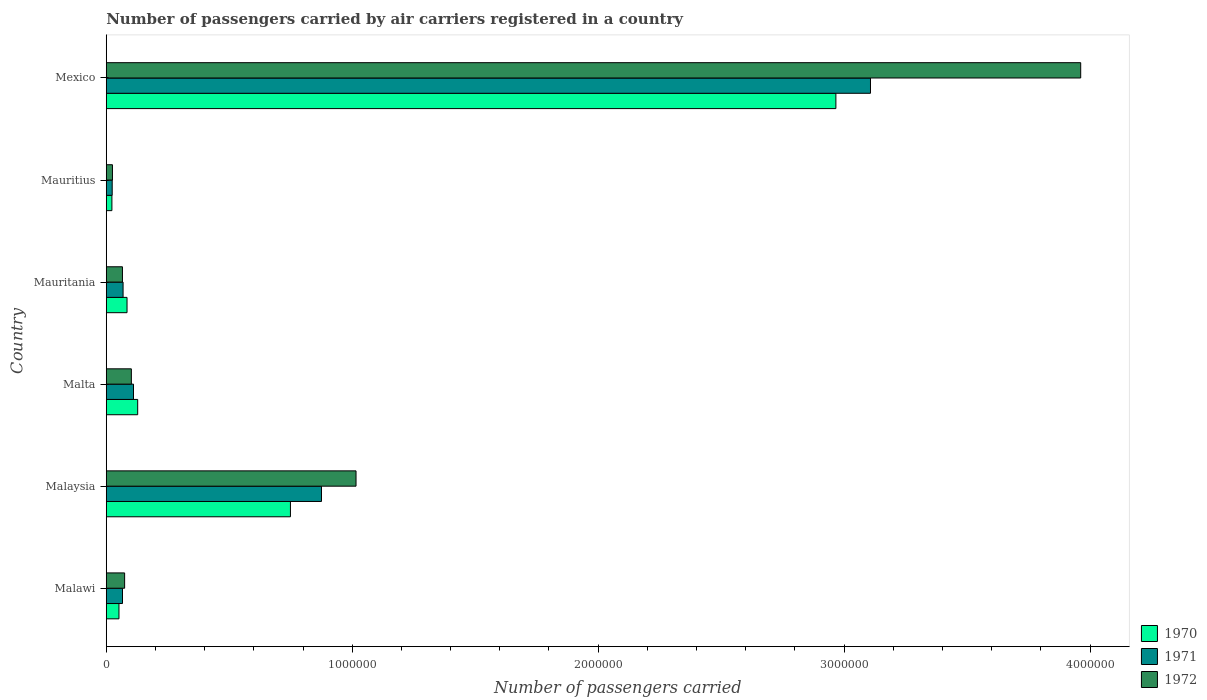How many different coloured bars are there?
Your response must be concise. 3. Are the number of bars on each tick of the Y-axis equal?
Provide a succinct answer. Yes. How many bars are there on the 1st tick from the top?
Offer a very short reply. 3. What is the label of the 6th group of bars from the top?
Provide a succinct answer. Malawi. What is the number of passengers carried by air carriers in 1971 in Malawi?
Make the answer very short. 6.61e+04. Across all countries, what is the maximum number of passengers carried by air carriers in 1971?
Ensure brevity in your answer.  3.11e+06. Across all countries, what is the minimum number of passengers carried by air carriers in 1971?
Keep it short and to the point. 2.42e+04. In which country was the number of passengers carried by air carriers in 1972 maximum?
Make the answer very short. Mexico. In which country was the number of passengers carried by air carriers in 1972 minimum?
Your response must be concise. Mauritius. What is the total number of passengers carried by air carriers in 1971 in the graph?
Your answer should be compact. 4.25e+06. What is the difference between the number of passengers carried by air carriers in 1970 in Malawi and that in Malta?
Offer a terse response. -7.61e+04. What is the difference between the number of passengers carried by air carriers in 1971 in Malta and the number of passengers carried by air carriers in 1972 in Mexico?
Your answer should be very brief. -3.85e+06. What is the average number of passengers carried by air carriers in 1972 per country?
Offer a terse response. 8.74e+05. What is the difference between the number of passengers carried by air carriers in 1972 and number of passengers carried by air carriers in 1970 in Malaysia?
Offer a very short reply. 2.67e+05. What is the ratio of the number of passengers carried by air carriers in 1972 in Malawi to that in Mauritius?
Your answer should be compact. 2.96. Is the number of passengers carried by air carriers in 1972 in Malaysia less than that in Mexico?
Offer a terse response. Yes. Is the difference between the number of passengers carried by air carriers in 1972 in Malaysia and Mauritius greater than the difference between the number of passengers carried by air carriers in 1970 in Malaysia and Mauritius?
Provide a short and direct response. Yes. What is the difference between the highest and the second highest number of passengers carried by air carriers in 1971?
Provide a succinct answer. 2.23e+06. What is the difference between the highest and the lowest number of passengers carried by air carriers in 1970?
Offer a very short reply. 2.94e+06. In how many countries, is the number of passengers carried by air carriers in 1970 greater than the average number of passengers carried by air carriers in 1970 taken over all countries?
Offer a terse response. 2. What does the 2nd bar from the top in Malaysia represents?
Provide a succinct answer. 1971. Are all the bars in the graph horizontal?
Your answer should be very brief. Yes. What is the difference between two consecutive major ticks on the X-axis?
Your answer should be compact. 1.00e+06. Are the values on the major ticks of X-axis written in scientific E-notation?
Provide a short and direct response. No. Does the graph contain any zero values?
Provide a succinct answer. No. How are the legend labels stacked?
Your answer should be compact. Vertical. What is the title of the graph?
Ensure brevity in your answer.  Number of passengers carried by air carriers registered in a country. What is the label or title of the X-axis?
Offer a terse response. Number of passengers carried. What is the label or title of the Y-axis?
Give a very brief answer. Country. What is the Number of passengers carried of 1970 in Malawi?
Keep it short and to the point. 5.17e+04. What is the Number of passengers carried in 1971 in Malawi?
Give a very brief answer. 6.61e+04. What is the Number of passengers carried of 1972 in Malawi?
Your response must be concise. 7.47e+04. What is the Number of passengers carried in 1970 in Malaysia?
Offer a terse response. 7.49e+05. What is the Number of passengers carried of 1971 in Malaysia?
Your answer should be very brief. 8.75e+05. What is the Number of passengers carried of 1972 in Malaysia?
Offer a very short reply. 1.02e+06. What is the Number of passengers carried in 1970 in Malta?
Keep it short and to the point. 1.28e+05. What is the Number of passengers carried in 1971 in Malta?
Offer a very short reply. 1.11e+05. What is the Number of passengers carried in 1972 in Malta?
Your answer should be compact. 1.02e+05. What is the Number of passengers carried of 1970 in Mauritania?
Keep it short and to the point. 8.45e+04. What is the Number of passengers carried in 1971 in Mauritania?
Provide a short and direct response. 6.84e+04. What is the Number of passengers carried in 1972 in Mauritania?
Your response must be concise. 6.59e+04. What is the Number of passengers carried in 1970 in Mauritius?
Keep it short and to the point. 2.30e+04. What is the Number of passengers carried in 1971 in Mauritius?
Ensure brevity in your answer.  2.42e+04. What is the Number of passengers carried of 1972 in Mauritius?
Your answer should be very brief. 2.52e+04. What is the Number of passengers carried in 1970 in Mexico?
Your response must be concise. 2.97e+06. What is the Number of passengers carried in 1971 in Mexico?
Provide a short and direct response. 3.11e+06. What is the Number of passengers carried in 1972 in Mexico?
Offer a terse response. 3.96e+06. Across all countries, what is the maximum Number of passengers carried of 1970?
Give a very brief answer. 2.97e+06. Across all countries, what is the maximum Number of passengers carried in 1971?
Keep it short and to the point. 3.11e+06. Across all countries, what is the maximum Number of passengers carried of 1972?
Provide a succinct answer. 3.96e+06. Across all countries, what is the minimum Number of passengers carried in 1970?
Provide a short and direct response. 2.30e+04. Across all countries, what is the minimum Number of passengers carried in 1971?
Keep it short and to the point. 2.42e+04. Across all countries, what is the minimum Number of passengers carried of 1972?
Offer a terse response. 2.52e+04. What is the total Number of passengers carried in 1970 in the graph?
Give a very brief answer. 4.00e+06. What is the total Number of passengers carried in 1971 in the graph?
Offer a terse response. 4.25e+06. What is the total Number of passengers carried of 1972 in the graph?
Ensure brevity in your answer.  5.25e+06. What is the difference between the Number of passengers carried in 1970 in Malawi and that in Malaysia?
Your answer should be very brief. -6.97e+05. What is the difference between the Number of passengers carried of 1971 in Malawi and that in Malaysia?
Provide a short and direct response. -8.09e+05. What is the difference between the Number of passengers carried in 1972 in Malawi and that in Malaysia?
Give a very brief answer. -9.41e+05. What is the difference between the Number of passengers carried in 1970 in Malawi and that in Malta?
Your answer should be compact. -7.61e+04. What is the difference between the Number of passengers carried in 1971 in Malawi and that in Malta?
Give a very brief answer. -4.47e+04. What is the difference between the Number of passengers carried in 1972 in Malawi and that in Malta?
Provide a short and direct response. -2.74e+04. What is the difference between the Number of passengers carried of 1970 in Malawi and that in Mauritania?
Ensure brevity in your answer.  -3.28e+04. What is the difference between the Number of passengers carried in 1971 in Malawi and that in Mauritania?
Your answer should be very brief. -2300. What is the difference between the Number of passengers carried in 1972 in Malawi and that in Mauritania?
Provide a succinct answer. 8800. What is the difference between the Number of passengers carried in 1970 in Malawi and that in Mauritius?
Your answer should be compact. 2.87e+04. What is the difference between the Number of passengers carried of 1971 in Malawi and that in Mauritius?
Your answer should be very brief. 4.19e+04. What is the difference between the Number of passengers carried in 1972 in Malawi and that in Mauritius?
Provide a short and direct response. 4.95e+04. What is the difference between the Number of passengers carried of 1970 in Malawi and that in Mexico?
Offer a terse response. -2.91e+06. What is the difference between the Number of passengers carried in 1971 in Malawi and that in Mexico?
Make the answer very short. -3.04e+06. What is the difference between the Number of passengers carried in 1972 in Malawi and that in Mexico?
Your answer should be compact. -3.89e+06. What is the difference between the Number of passengers carried in 1970 in Malaysia and that in Malta?
Make the answer very short. 6.21e+05. What is the difference between the Number of passengers carried in 1971 in Malaysia and that in Malta?
Keep it short and to the point. 7.64e+05. What is the difference between the Number of passengers carried in 1972 in Malaysia and that in Malta?
Make the answer very short. 9.14e+05. What is the difference between the Number of passengers carried of 1970 in Malaysia and that in Mauritania?
Provide a succinct answer. 6.64e+05. What is the difference between the Number of passengers carried of 1971 in Malaysia and that in Mauritania?
Offer a terse response. 8.07e+05. What is the difference between the Number of passengers carried of 1972 in Malaysia and that in Mauritania?
Offer a very short reply. 9.50e+05. What is the difference between the Number of passengers carried of 1970 in Malaysia and that in Mauritius?
Keep it short and to the point. 7.26e+05. What is the difference between the Number of passengers carried in 1971 in Malaysia and that in Mauritius?
Offer a terse response. 8.51e+05. What is the difference between the Number of passengers carried of 1972 in Malaysia and that in Mauritius?
Keep it short and to the point. 9.90e+05. What is the difference between the Number of passengers carried of 1970 in Malaysia and that in Mexico?
Ensure brevity in your answer.  -2.22e+06. What is the difference between the Number of passengers carried in 1971 in Malaysia and that in Mexico?
Make the answer very short. -2.23e+06. What is the difference between the Number of passengers carried in 1972 in Malaysia and that in Mexico?
Make the answer very short. -2.95e+06. What is the difference between the Number of passengers carried in 1970 in Malta and that in Mauritania?
Make the answer very short. 4.33e+04. What is the difference between the Number of passengers carried in 1971 in Malta and that in Mauritania?
Offer a very short reply. 4.24e+04. What is the difference between the Number of passengers carried of 1972 in Malta and that in Mauritania?
Your answer should be very brief. 3.62e+04. What is the difference between the Number of passengers carried in 1970 in Malta and that in Mauritius?
Ensure brevity in your answer.  1.05e+05. What is the difference between the Number of passengers carried in 1971 in Malta and that in Mauritius?
Your response must be concise. 8.66e+04. What is the difference between the Number of passengers carried of 1972 in Malta and that in Mauritius?
Offer a very short reply. 7.69e+04. What is the difference between the Number of passengers carried of 1970 in Malta and that in Mexico?
Ensure brevity in your answer.  -2.84e+06. What is the difference between the Number of passengers carried in 1971 in Malta and that in Mexico?
Make the answer very short. -3.00e+06. What is the difference between the Number of passengers carried in 1972 in Malta and that in Mexico?
Give a very brief answer. -3.86e+06. What is the difference between the Number of passengers carried in 1970 in Mauritania and that in Mauritius?
Offer a terse response. 6.15e+04. What is the difference between the Number of passengers carried in 1971 in Mauritania and that in Mauritius?
Provide a succinct answer. 4.42e+04. What is the difference between the Number of passengers carried of 1972 in Mauritania and that in Mauritius?
Keep it short and to the point. 4.07e+04. What is the difference between the Number of passengers carried of 1970 in Mauritania and that in Mexico?
Offer a very short reply. -2.88e+06. What is the difference between the Number of passengers carried in 1971 in Mauritania and that in Mexico?
Provide a succinct answer. -3.04e+06. What is the difference between the Number of passengers carried of 1972 in Mauritania and that in Mexico?
Keep it short and to the point. -3.90e+06. What is the difference between the Number of passengers carried in 1970 in Mauritius and that in Mexico?
Make the answer very short. -2.94e+06. What is the difference between the Number of passengers carried in 1971 in Mauritius and that in Mexico?
Ensure brevity in your answer.  -3.08e+06. What is the difference between the Number of passengers carried of 1972 in Mauritius and that in Mexico?
Offer a terse response. -3.94e+06. What is the difference between the Number of passengers carried of 1970 in Malawi and the Number of passengers carried of 1971 in Malaysia?
Keep it short and to the point. -8.23e+05. What is the difference between the Number of passengers carried in 1970 in Malawi and the Number of passengers carried in 1972 in Malaysia?
Keep it short and to the point. -9.64e+05. What is the difference between the Number of passengers carried in 1971 in Malawi and the Number of passengers carried in 1972 in Malaysia?
Give a very brief answer. -9.50e+05. What is the difference between the Number of passengers carried in 1970 in Malawi and the Number of passengers carried in 1971 in Malta?
Your answer should be compact. -5.91e+04. What is the difference between the Number of passengers carried in 1970 in Malawi and the Number of passengers carried in 1972 in Malta?
Your answer should be very brief. -5.04e+04. What is the difference between the Number of passengers carried of 1971 in Malawi and the Number of passengers carried of 1972 in Malta?
Offer a terse response. -3.60e+04. What is the difference between the Number of passengers carried of 1970 in Malawi and the Number of passengers carried of 1971 in Mauritania?
Give a very brief answer. -1.67e+04. What is the difference between the Number of passengers carried of 1970 in Malawi and the Number of passengers carried of 1972 in Mauritania?
Provide a short and direct response. -1.42e+04. What is the difference between the Number of passengers carried of 1970 in Malawi and the Number of passengers carried of 1971 in Mauritius?
Ensure brevity in your answer.  2.75e+04. What is the difference between the Number of passengers carried of 1970 in Malawi and the Number of passengers carried of 1972 in Mauritius?
Make the answer very short. 2.65e+04. What is the difference between the Number of passengers carried of 1971 in Malawi and the Number of passengers carried of 1972 in Mauritius?
Your answer should be compact. 4.09e+04. What is the difference between the Number of passengers carried of 1970 in Malawi and the Number of passengers carried of 1971 in Mexico?
Keep it short and to the point. -3.06e+06. What is the difference between the Number of passengers carried in 1970 in Malawi and the Number of passengers carried in 1972 in Mexico?
Make the answer very short. -3.91e+06. What is the difference between the Number of passengers carried of 1971 in Malawi and the Number of passengers carried of 1972 in Mexico?
Give a very brief answer. -3.90e+06. What is the difference between the Number of passengers carried in 1970 in Malaysia and the Number of passengers carried in 1971 in Malta?
Your answer should be very brief. 6.38e+05. What is the difference between the Number of passengers carried in 1970 in Malaysia and the Number of passengers carried in 1972 in Malta?
Provide a succinct answer. 6.47e+05. What is the difference between the Number of passengers carried in 1971 in Malaysia and the Number of passengers carried in 1972 in Malta?
Provide a short and direct response. 7.73e+05. What is the difference between the Number of passengers carried of 1970 in Malaysia and the Number of passengers carried of 1971 in Mauritania?
Offer a very short reply. 6.80e+05. What is the difference between the Number of passengers carried in 1970 in Malaysia and the Number of passengers carried in 1972 in Mauritania?
Offer a very short reply. 6.83e+05. What is the difference between the Number of passengers carried of 1971 in Malaysia and the Number of passengers carried of 1972 in Mauritania?
Offer a terse response. 8.09e+05. What is the difference between the Number of passengers carried of 1970 in Malaysia and the Number of passengers carried of 1971 in Mauritius?
Ensure brevity in your answer.  7.25e+05. What is the difference between the Number of passengers carried of 1970 in Malaysia and the Number of passengers carried of 1972 in Mauritius?
Provide a short and direct response. 7.24e+05. What is the difference between the Number of passengers carried of 1971 in Malaysia and the Number of passengers carried of 1972 in Mauritius?
Your answer should be compact. 8.50e+05. What is the difference between the Number of passengers carried in 1970 in Malaysia and the Number of passengers carried in 1971 in Mexico?
Keep it short and to the point. -2.36e+06. What is the difference between the Number of passengers carried in 1970 in Malaysia and the Number of passengers carried in 1972 in Mexico?
Provide a succinct answer. -3.21e+06. What is the difference between the Number of passengers carried of 1971 in Malaysia and the Number of passengers carried of 1972 in Mexico?
Your answer should be very brief. -3.09e+06. What is the difference between the Number of passengers carried in 1970 in Malta and the Number of passengers carried in 1971 in Mauritania?
Your response must be concise. 5.94e+04. What is the difference between the Number of passengers carried of 1970 in Malta and the Number of passengers carried of 1972 in Mauritania?
Your response must be concise. 6.19e+04. What is the difference between the Number of passengers carried of 1971 in Malta and the Number of passengers carried of 1972 in Mauritania?
Keep it short and to the point. 4.49e+04. What is the difference between the Number of passengers carried of 1970 in Malta and the Number of passengers carried of 1971 in Mauritius?
Give a very brief answer. 1.04e+05. What is the difference between the Number of passengers carried of 1970 in Malta and the Number of passengers carried of 1972 in Mauritius?
Your answer should be very brief. 1.03e+05. What is the difference between the Number of passengers carried of 1971 in Malta and the Number of passengers carried of 1972 in Mauritius?
Your response must be concise. 8.56e+04. What is the difference between the Number of passengers carried of 1970 in Malta and the Number of passengers carried of 1971 in Mexico?
Give a very brief answer. -2.98e+06. What is the difference between the Number of passengers carried in 1970 in Malta and the Number of passengers carried in 1972 in Mexico?
Keep it short and to the point. -3.83e+06. What is the difference between the Number of passengers carried in 1971 in Malta and the Number of passengers carried in 1972 in Mexico?
Make the answer very short. -3.85e+06. What is the difference between the Number of passengers carried of 1970 in Mauritania and the Number of passengers carried of 1971 in Mauritius?
Provide a short and direct response. 6.03e+04. What is the difference between the Number of passengers carried of 1970 in Mauritania and the Number of passengers carried of 1972 in Mauritius?
Make the answer very short. 5.93e+04. What is the difference between the Number of passengers carried of 1971 in Mauritania and the Number of passengers carried of 1972 in Mauritius?
Provide a short and direct response. 4.32e+04. What is the difference between the Number of passengers carried in 1970 in Mauritania and the Number of passengers carried in 1971 in Mexico?
Offer a terse response. -3.02e+06. What is the difference between the Number of passengers carried of 1970 in Mauritania and the Number of passengers carried of 1972 in Mexico?
Provide a short and direct response. -3.88e+06. What is the difference between the Number of passengers carried in 1971 in Mauritania and the Number of passengers carried in 1972 in Mexico?
Your response must be concise. -3.89e+06. What is the difference between the Number of passengers carried in 1970 in Mauritius and the Number of passengers carried in 1971 in Mexico?
Keep it short and to the point. -3.08e+06. What is the difference between the Number of passengers carried in 1970 in Mauritius and the Number of passengers carried in 1972 in Mexico?
Provide a short and direct response. -3.94e+06. What is the difference between the Number of passengers carried of 1971 in Mauritius and the Number of passengers carried of 1972 in Mexico?
Provide a short and direct response. -3.94e+06. What is the average Number of passengers carried in 1970 per country?
Your answer should be compact. 6.67e+05. What is the average Number of passengers carried of 1971 per country?
Your answer should be very brief. 7.09e+05. What is the average Number of passengers carried in 1972 per country?
Your answer should be very brief. 8.74e+05. What is the difference between the Number of passengers carried of 1970 and Number of passengers carried of 1971 in Malawi?
Make the answer very short. -1.44e+04. What is the difference between the Number of passengers carried of 1970 and Number of passengers carried of 1972 in Malawi?
Provide a succinct answer. -2.30e+04. What is the difference between the Number of passengers carried of 1971 and Number of passengers carried of 1972 in Malawi?
Offer a very short reply. -8600. What is the difference between the Number of passengers carried of 1970 and Number of passengers carried of 1971 in Malaysia?
Keep it short and to the point. -1.26e+05. What is the difference between the Number of passengers carried of 1970 and Number of passengers carried of 1972 in Malaysia?
Provide a short and direct response. -2.67e+05. What is the difference between the Number of passengers carried of 1971 and Number of passengers carried of 1972 in Malaysia?
Your answer should be very brief. -1.40e+05. What is the difference between the Number of passengers carried in 1970 and Number of passengers carried in 1971 in Malta?
Your answer should be very brief. 1.70e+04. What is the difference between the Number of passengers carried in 1970 and Number of passengers carried in 1972 in Malta?
Your response must be concise. 2.57e+04. What is the difference between the Number of passengers carried of 1971 and Number of passengers carried of 1972 in Malta?
Give a very brief answer. 8700. What is the difference between the Number of passengers carried in 1970 and Number of passengers carried in 1971 in Mauritania?
Provide a succinct answer. 1.61e+04. What is the difference between the Number of passengers carried of 1970 and Number of passengers carried of 1972 in Mauritania?
Offer a very short reply. 1.86e+04. What is the difference between the Number of passengers carried of 1971 and Number of passengers carried of 1972 in Mauritania?
Your answer should be compact. 2500. What is the difference between the Number of passengers carried of 1970 and Number of passengers carried of 1971 in Mauritius?
Your answer should be very brief. -1200. What is the difference between the Number of passengers carried of 1970 and Number of passengers carried of 1972 in Mauritius?
Provide a succinct answer. -2200. What is the difference between the Number of passengers carried in 1971 and Number of passengers carried in 1972 in Mauritius?
Give a very brief answer. -1000. What is the difference between the Number of passengers carried of 1970 and Number of passengers carried of 1971 in Mexico?
Provide a short and direct response. -1.41e+05. What is the difference between the Number of passengers carried of 1970 and Number of passengers carried of 1972 in Mexico?
Offer a very short reply. -9.95e+05. What is the difference between the Number of passengers carried of 1971 and Number of passengers carried of 1972 in Mexico?
Give a very brief answer. -8.55e+05. What is the ratio of the Number of passengers carried in 1970 in Malawi to that in Malaysia?
Your response must be concise. 0.07. What is the ratio of the Number of passengers carried in 1971 in Malawi to that in Malaysia?
Offer a terse response. 0.08. What is the ratio of the Number of passengers carried in 1972 in Malawi to that in Malaysia?
Your response must be concise. 0.07. What is the ratio of the Number of passengers carried of 1970 in Malawi to that in Malta?
Offer a terse response. 0.4. What is the ratio of the Number of passengers carried in 1971 in Malawi to that in Malta?
Provide a succinct answer. 0.6. What is the ratio of the Number of passengers carried in 1972 in Malawi to that in Malta?
Ensure brevity in your answer.  0.73. What is the ratio of the Number of passengers carried in 1970 in Malawi to that in Mauritania?
Offer a very short reply. 0.61. What is the ratio of the Number of passengers carried in 1971 in Malawi to that in Mauritania?
Make the answer very short. 0.97. What is the ratio of the Number of passengers carried of 1972 in Malawi to that in Mauritania?
Provide a succinct answer. 1.13. What is the ratio of the Number of passengers carried of 1970 in Malawi to that in Mauritius?
Provide a short and direct response. 2.25. What is the ratio of the Number of passengers carried in 1971 in Malawi to that in Mauritius?
Your answer should be compact. 2.73. What is the ratio of the Number of passengers carried of 1972 in Malawi to that in Mauritius?
Your answer should be compact. 2.96. What is the ratio of the Number of passengers carried of 1970 in Malawi to that in Mexico?
Your response must be concise. 0.02. What is the ratio of the Number of passengers carried in 1971 in Malawi to that in Mexico?
Keep it short and to the point. 0.02. What is the ratio of the Number of passengers carried in 1972 in Malawi to that in Mexico?
Your response must be concise. 0.02. What is the ratio of the Number of passengers carried in 1970 in Malaysia to that in Malta?
Make the answer very short. 5.86. What is the ratio of the Number of passengers carried of 1971 in Malaysia to that in Malta?
Your answer should be compact. 7.9. What is the ratio of the Number of passengers carried of 1972 in Malaysia to that in Malta?
Your answer should be compact. 9.95. What is the ratio of the Number of passengers carried of 1970 in Malaysia to that in Mauritania?
Make the answer very short. 8.86. What is the ratio of the Number of passengers carried of 1971 in Malaysia to that in Mauritania?
Your response must be concise. 12.79. What is the ratio of the Number of passengers carried of 1972 in Malaysia to that in Mauritania?
Make the answer very short. 15.41. What is the ratio of the Number of passengers carried in 1970 in Malaysia to that in Mauritius?
Offer a very short reply. 32.56. What is the ratio of the Number of passengers carried in 1971 in Malaysia to that in Mauritius?
Provide a short and direct response. 36.16. What is the ratio of the Number of passengers carried in 1972 in Malaysia to that in Mauritius?
Provide a succinct answer. 40.3. What is the ratio of the Number of passengers carried of 1970 in Malaysia to that in Mexico?
Your answer should be compact. 0.25. What is the ratio of the Number of passengers carried of 1971 in Malaysia to that in Mexico?
Ensure brevity in your answer.  0.28. What is the ratio of the Number of passengers carried in 1972 in Malaysia to that in Mexico?
Your answer should be very brief. 0.26. What is the ratio of the Number of passengers carried in 1970 in Malta to that in Mauritania?
Your answer should be compact. 1.51. What is the ratio of the Number of passengers carried in 1971 in Malta to that in Mauritania?
Give a very brief answer. 1.62. What is the ratio of the Number of passengers carried in 1972 in Malta to that in Mauritania?
Your answer should be very brief. 1.55. What is the ratio of the Number of passengers carried in 1970 in Malta to that in Mauritius?
Provide a short and direct response. 5.56. What is the ratio of the Number of passengers carried in 1971 in Malta to that in Mauritius?
Provide a short and direct response. 4.58. What is the ratio of the Number of passengers carried of 1972 in Malta to that in Mauritius?
Offer a terse response. 4.05. What is the ratio of the Number of passengers carried in 1970 in Malta to that in Mexico?
Provide a succinct answer. 0.04. What is the ratio of the Number of passengers carried in 1971 in Malta to that in Mexico?
Ensure brevity in your answer.  0.04. What is the ratio of the Number of passengers carried in 1972 in Malta to that in Mexico?
Your response must be concise. 0.03. What is the ratio of the Number of passengers carried in 1970 in Mauritania to that in Mauritius?
Provide a succinct answer. 3.67. What is the ratio of the Number of passengers carried in 1971 in Mauritania to that in Mauritius?
Keep it short and to the point. 2.83. What is the ratio of the Number of passengers carried in 1972 in Mauritania to that in Mauritius?
Provide a succinct answer. 2.62. What is the ratio of the Number of passengers carried of 1970 in Mauritania to that in Mexico?
Offer a very short reply. 0.03. What is the ratio of the Number of passengers carried in 1971 in Mauritania to that in Mexico?
Your response must be concise. 0.02. What is the ratio of the Number of passengers carried in 1972 in Mauritania to that in Mexico?
Provide a succinct answer. 0.02. What is the ratio of the Number of passengers carried in 1970 in Mauritius to that in Mexico?
Ensure brevity in your answer.  0.01. What is the ratio of the Number of passengers carried in 1971 in Mauritius to that in Mexico?
Offer a terse response. 0.01. What is the ratio of the Number of passengers carried of 1972 in Mauritius to that in Mexico?
Provide a short and direct response. 0.01. What is the difference between the highest and the second highest Number of passengers carried of 1970?
Ensure brevity in your answer.  2.22e+06. What is the difference between the highest and the second highest Number of passengers carried in 1971?
Offer a very short reply. 2.23e+06. What is the difference between the highest and the second highest Number of passengers carried of 1972?
Provide a succinct answer. 2.95e+06. What is the difference between the highest and the lowest Number of passengers carried in 1970?
Your answer should be compact. 2.94e+06. What is the difference between the highest and the lowest Number of passengers carried of 1971?
Provide a short and direct response. 3.08e+06. What is the difference between the highest and the lowest Number of passengers carried of 1972?
Keep it short and to the point. 3.94e+06. 